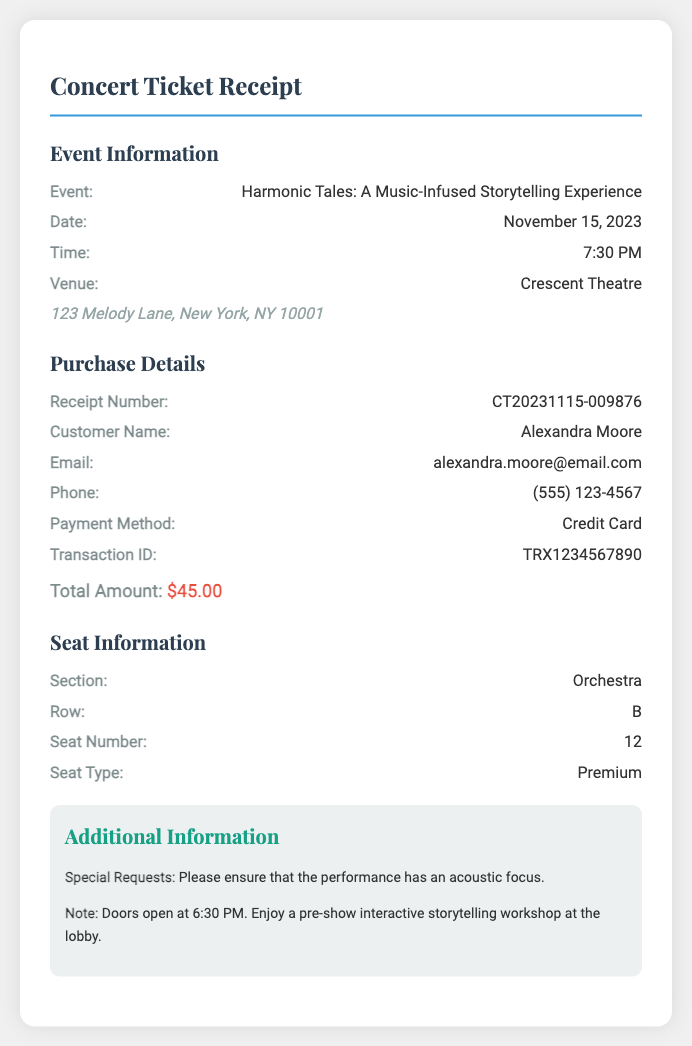What is the event name? The event name is provided in the document under Event Information.
Answer: Harmonic Tales: A Music-Infused Storytelling Experience What is the date of the event? The date is stated under Event Information.
Answer: November 15, 2023 What is the total amount paid? The total amount is listed in the Purchase Details section.
Answer: $45.00 What section is the seat located in? The section information is found under Seat Information.
Answer: Orchestra What time do the doors open? The door opening time is mentioned in the Additional Information section.
Answer: 6:30 PM What is the receipt number? The receipt number is found in the Purchase Details section.
Answer: CT20231115-009876 Who is the customer? The customer's name is listed under Purchase Details.
Answer: Alexandra Moore What type of seat was purchased? The seat type is detailed under Seat Information.
Answer: Premium What special request was made? The special request is mentioned in the Additional Information section.
Answer: Please ensure that the performance has an acoustic focus 